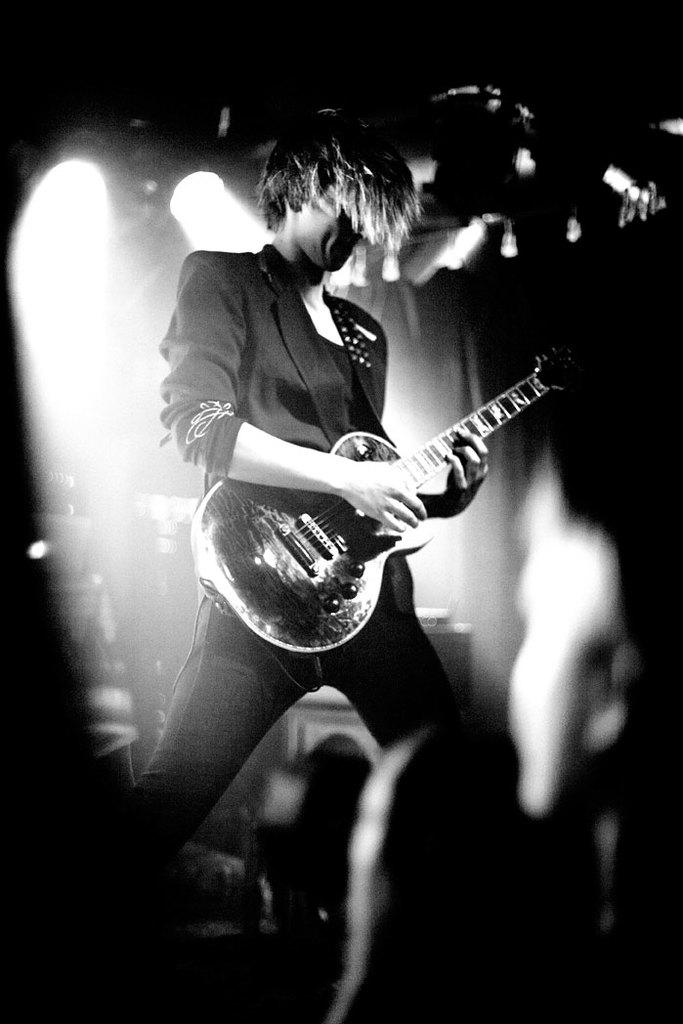Who or what is the main subject in the image? There is a person in the image. What is the person wearing? The person is wearing a black dress. What activity is the person engaged in? The person is playing a guitar. What type of mitten is the person wearing in the image? There is no mitten present in the image; the person is wearing a black dress. What type of bomb is the person holding in the image? There is no bomb present in the image; the person is playing a guitar. 